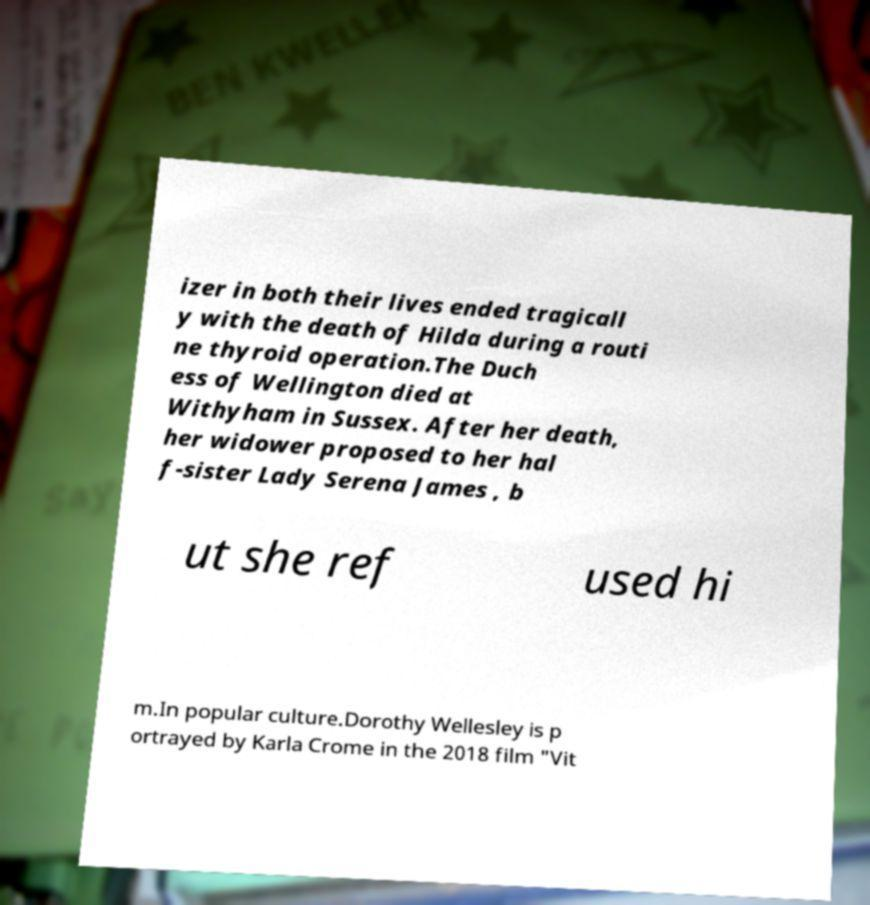Could you assist in decoding the text presented in this image and type it out clearly? izer in both their lives ended tragicall y with the death of Hilda during a routi ne thyroid operation.The Duch ess of Wellington died at Withyham in Sussex. After her death, her widower proposed to her hal f-sister Lady Serena James , b ut she ref used hi m.In popular culture.Dorothy Wellesley is p ortrayed by Karla Crome in the 2018 film "Vit 